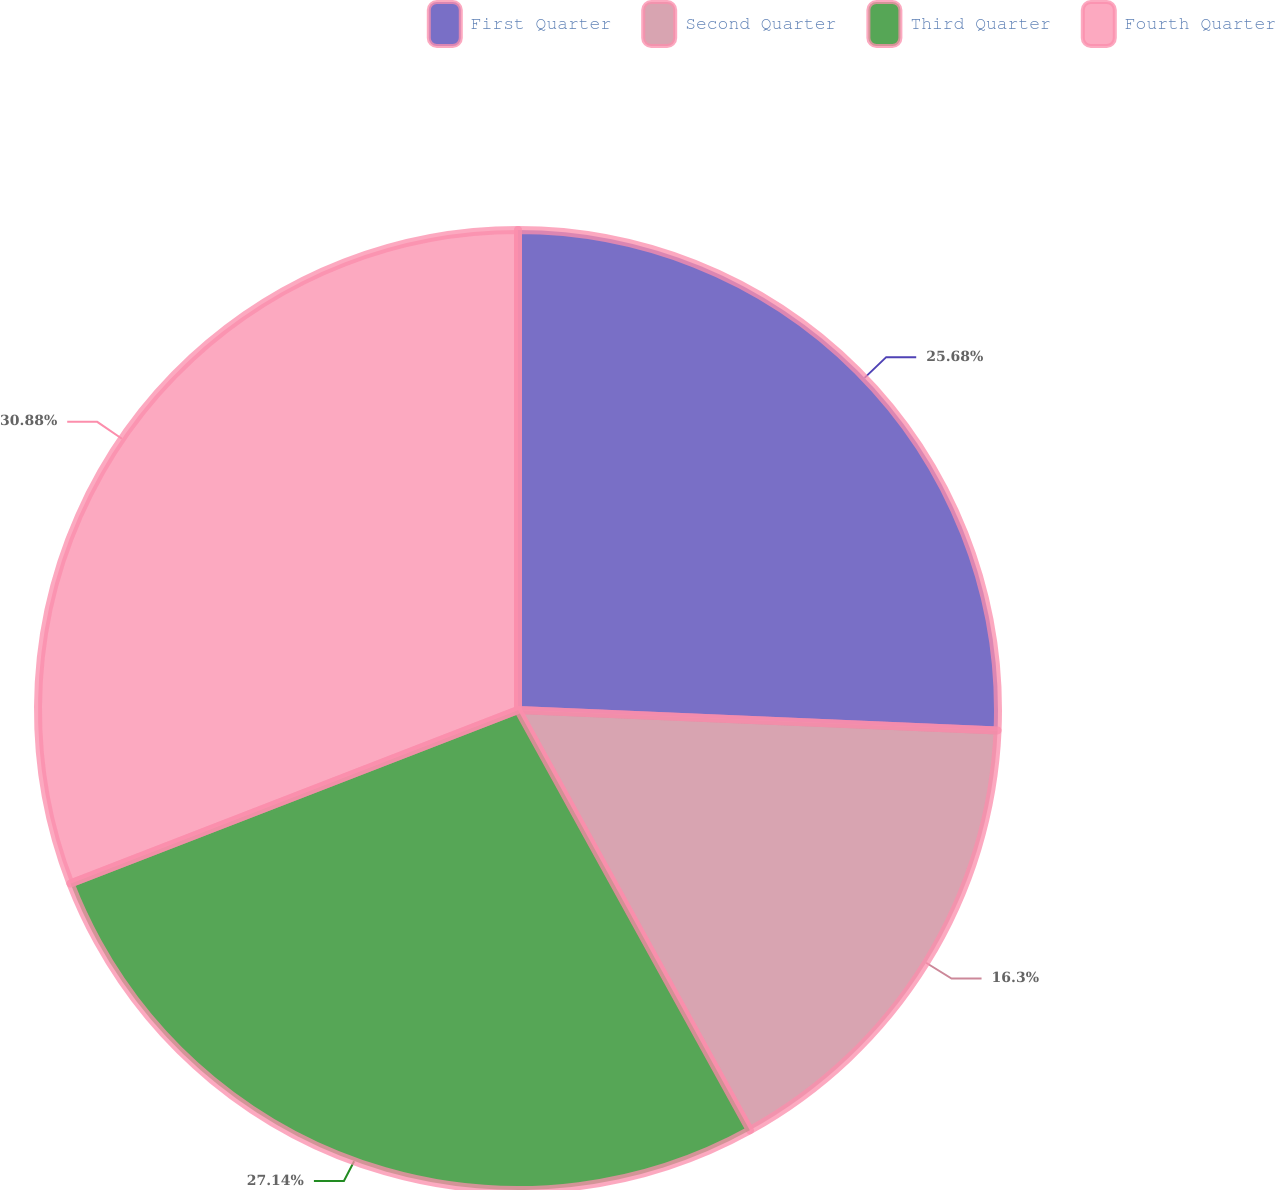Convert chart. <chart><loc_0><loc_0><loc_500><loc_500><pie_chart><fcel>First Quarter<fcel>Second Quarter<fcel>Third Quarter<fcel>Fourth Quarter<nl><fcel>25.68%<fcel>16.3%<fcel>27.14%<fcel>30.89%<nl></chart> 